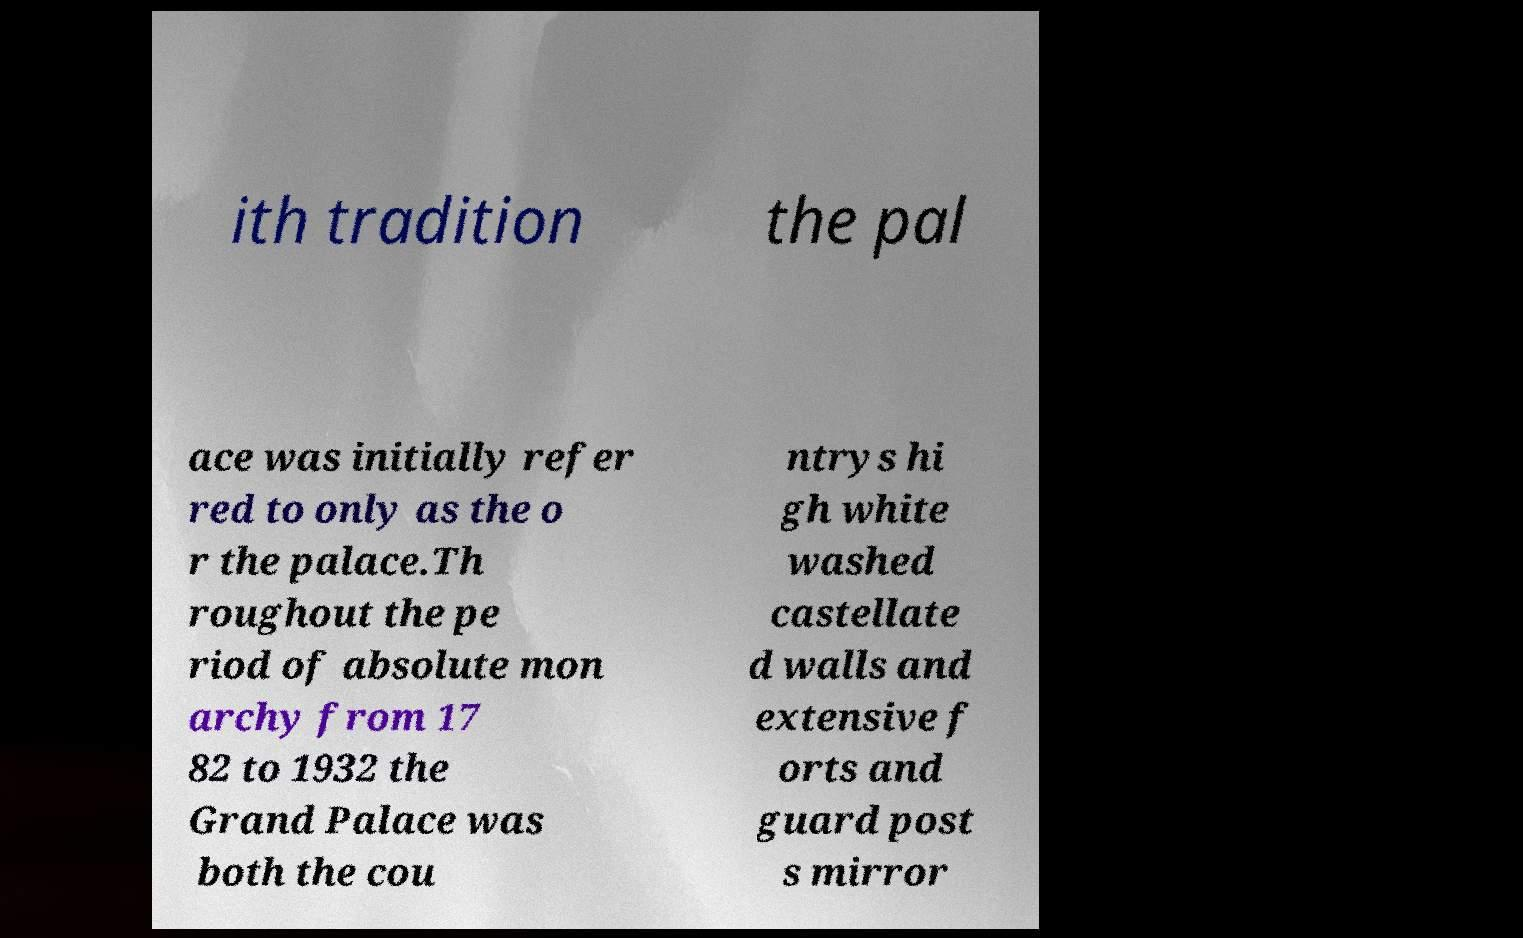Please identify and transcribe the text found in this image. ith tradition the pal ace was initially refer red to only as the o r the palace.Th roughout the pe riod of absolute mon archy from 17 82 to 1932 the Grand Palace was both the cou ntrys hi gh white washed castellate d walls and extensive f orts and guard post s mirror 